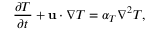<formula> <loc_0><loc_0><loc_500><loc_500>\frac { \partial T } { \partial t } + u \cdot \nabla T = \alpha _ { T } \nabla ^ { 2 } T ,</formula> 